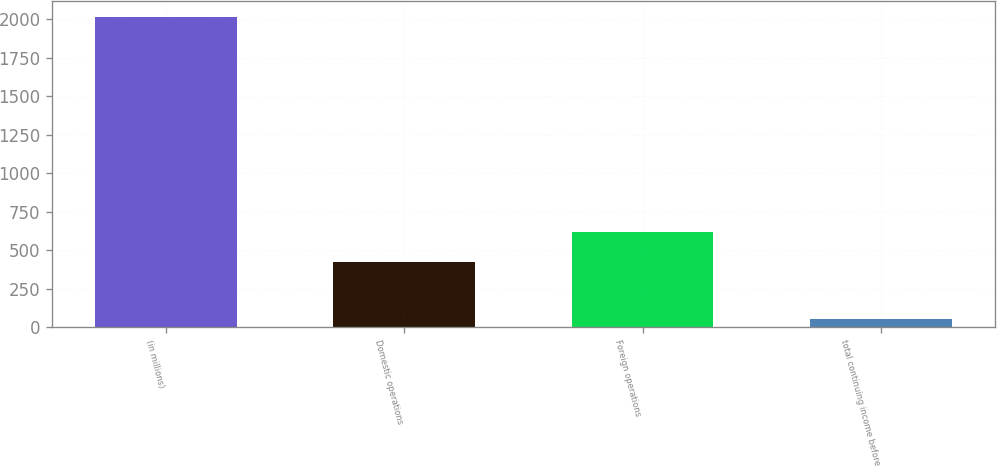Convert chart to OTSL. <chart><loc_0><loc_0><loc_500><loc_500><bar_chart><fcel>(in millions)<fcel>Domestic operations<fcel>Foreign operations<fcel>total continuing income before<nl><fcel>2014<fcel>423<fcel>619<fcel>54<nl></chart> 